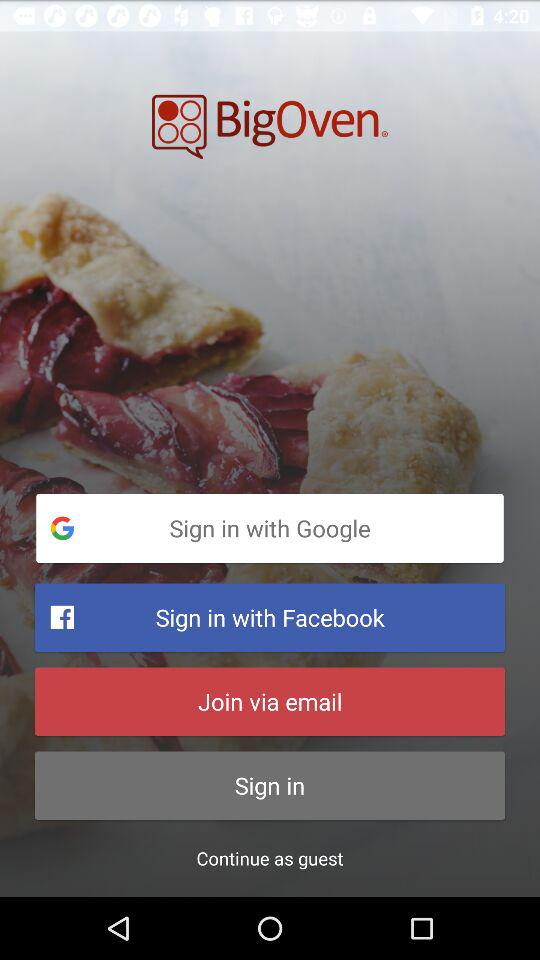What is the application name? The application name is "BigOven". 